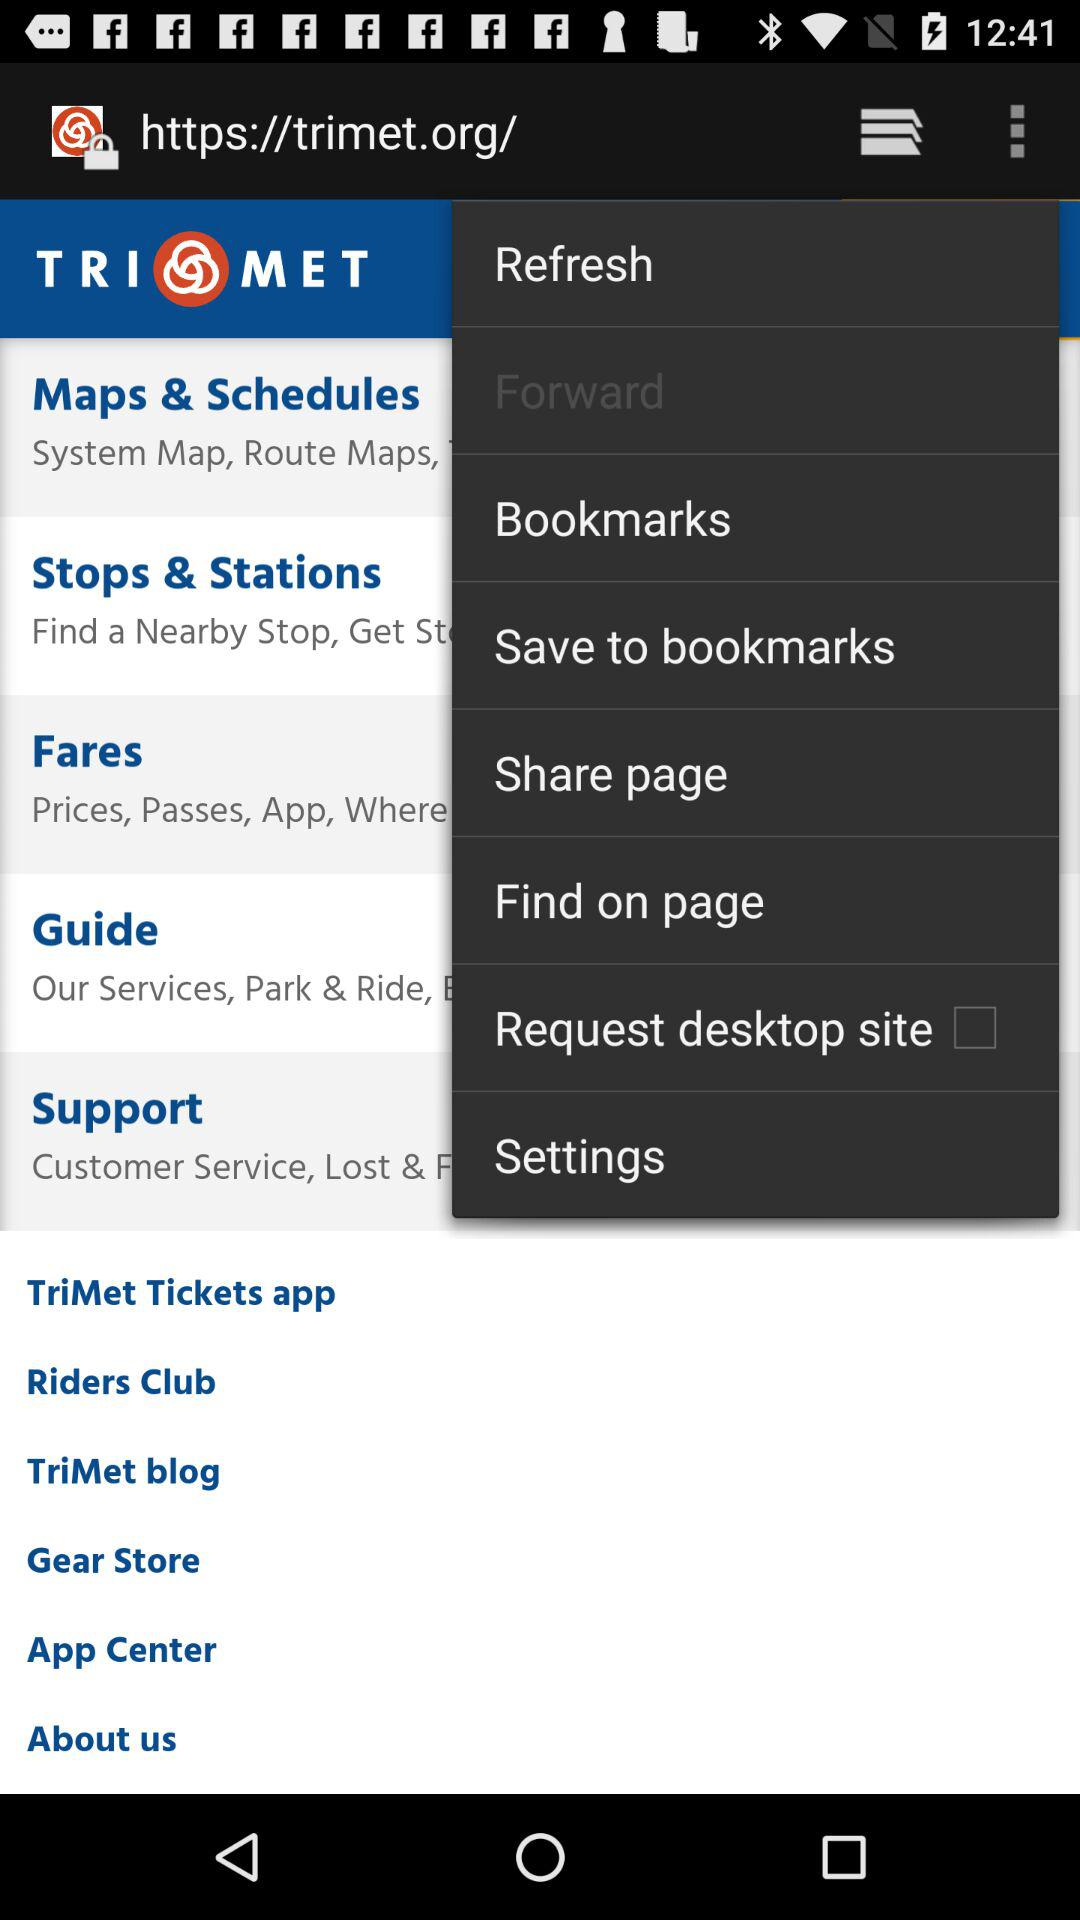What is the name of the application? The name of the application is "TriMet Tickets". 